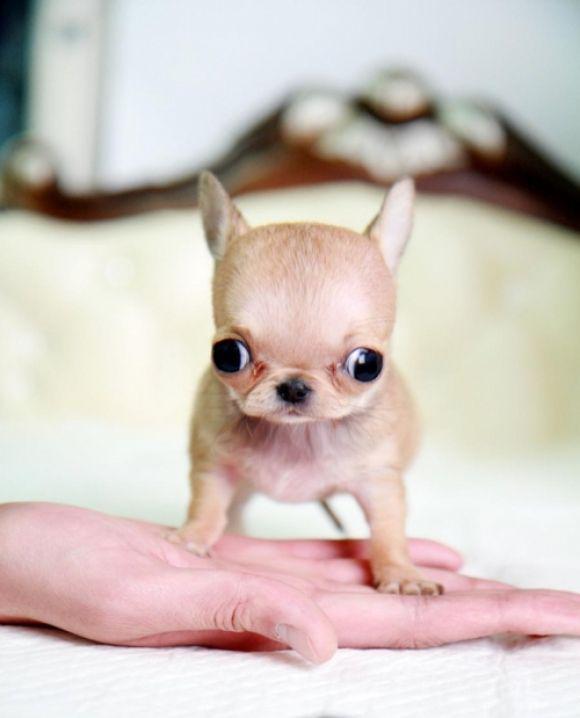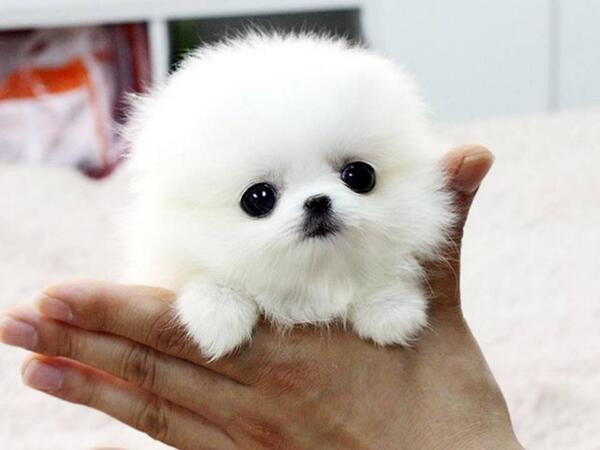The first image is the image on the left, the second image is the image on the right. Examine the images to the left and right. Is the description "Each image shows one teacup puppy displayed on a human hand, and the puppy on the right is solid white." accurate? Answer yes or no. Yes. The first image is the image on the left, the second image is the image on the right. Examine the images to the left and right. Is the description "Both images show one small dog in a person's hand" accurate? Answer yes or no. Yes. 